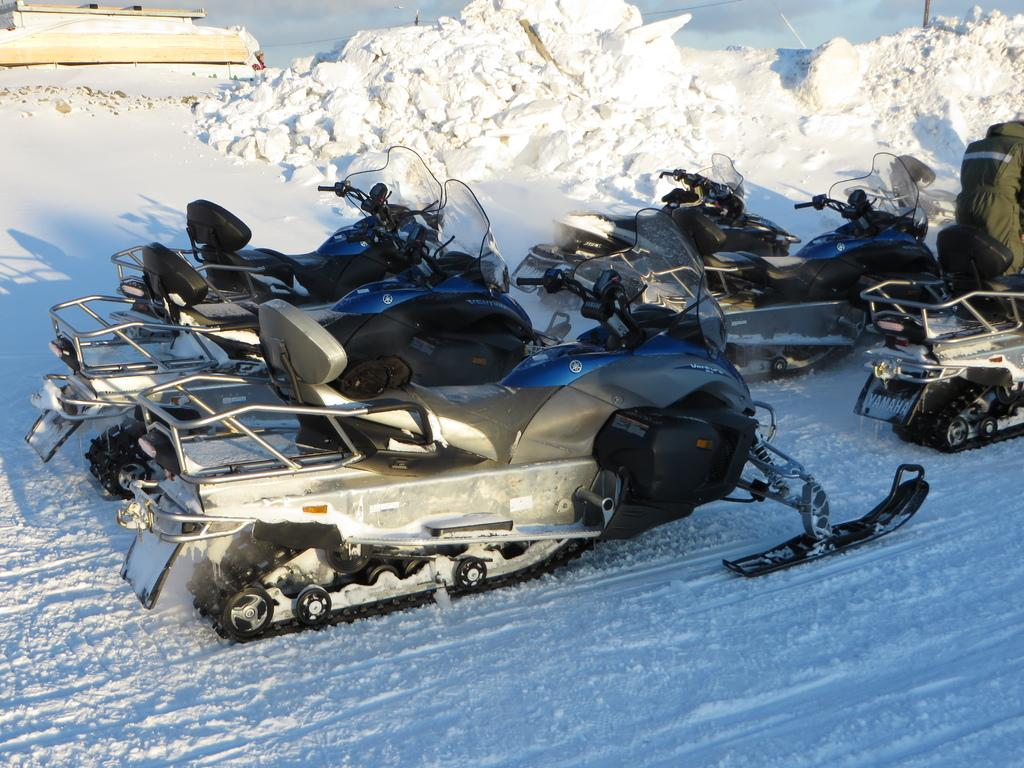What type of vehicles can be seen in the image? There are motor vehicles in the image. Where are the motor vehicles located? The motor vehicles are placed on the snow. What type of rice is being served in the image? There is no rice present in the image; it features motor vehicles on the snow. What is the price of the vehicles in the image? The image does not provide information about the price of the vehicles. 